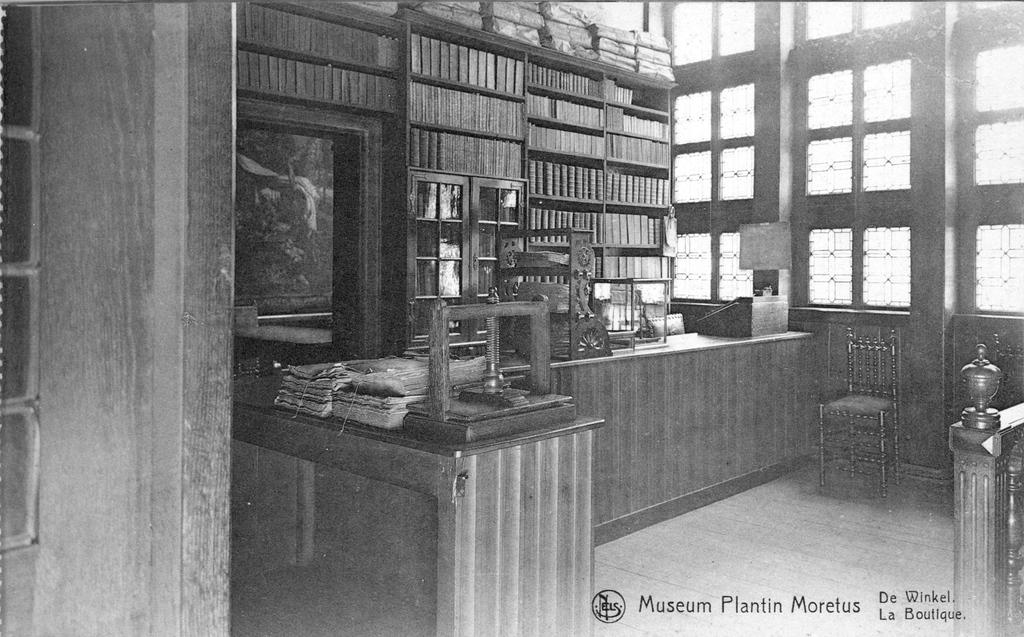Is this the museum plantin morelus?
Provide a succinct answer. Yes. What is the word next to la at the bottom of the picture?
Make the answer very short. Boutique. 